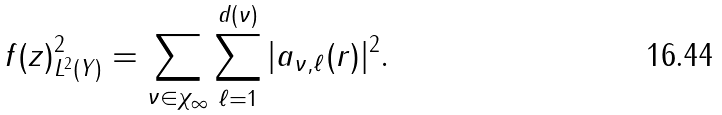<formula> <loc_0><loc_0><loc_500><loc_500>\| f ( z ) \| ^ { 2 } _ { L ^ { 2 } ( Y ) } = \sum _ { \nu \in \chi _ { \infty } } \sum _ { \ell = 1 } ^ { d ( \nu ) } | a _ { \nu , \ell } ( r ) | ^ { 2 } .</formula> 